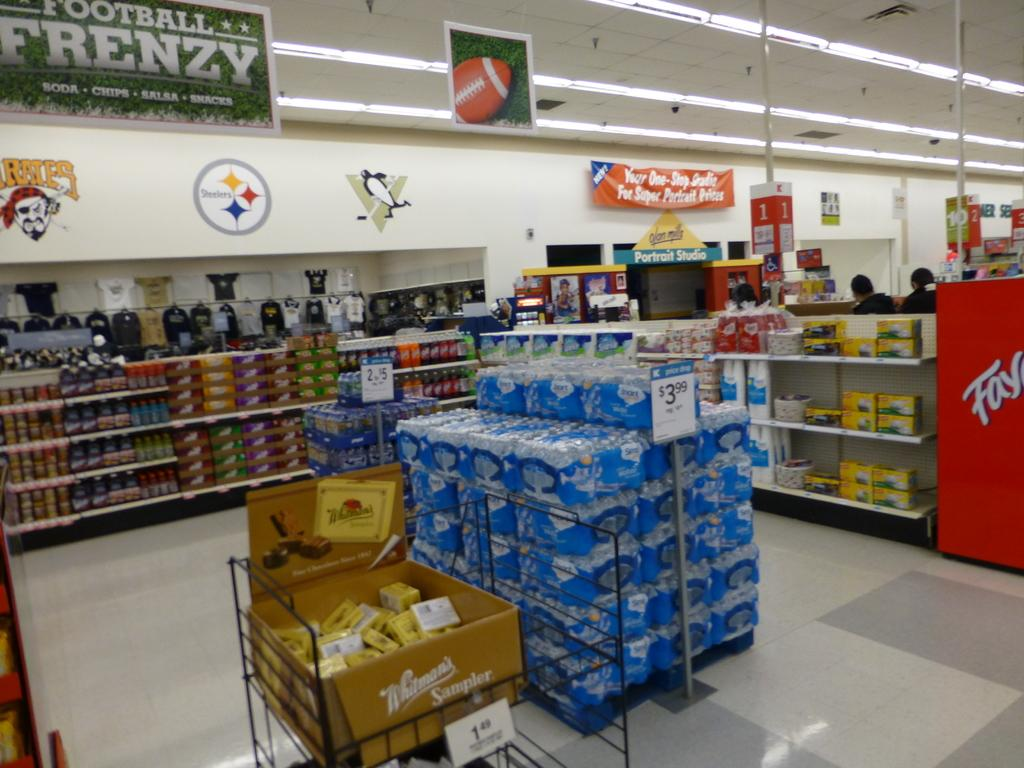<image>
Create a compact narrative representing the image presented. A sign for Football Frenzy hangs from a grocery store ceiling 